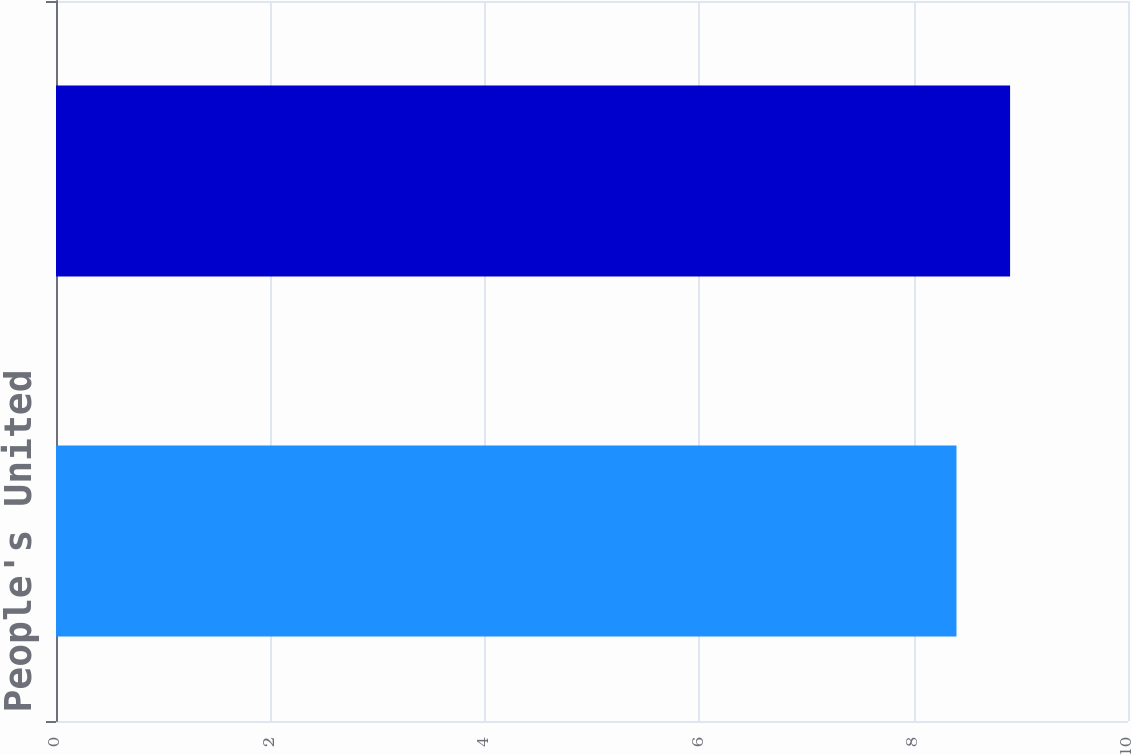Convert chart to OTSL. <chart><loc_0><loc_0><loc_500><loc_500><bar_chart><fcel>People's United<fcel>Bank<nl><fcel>8.4<fcel>8.9<nl></chart> 